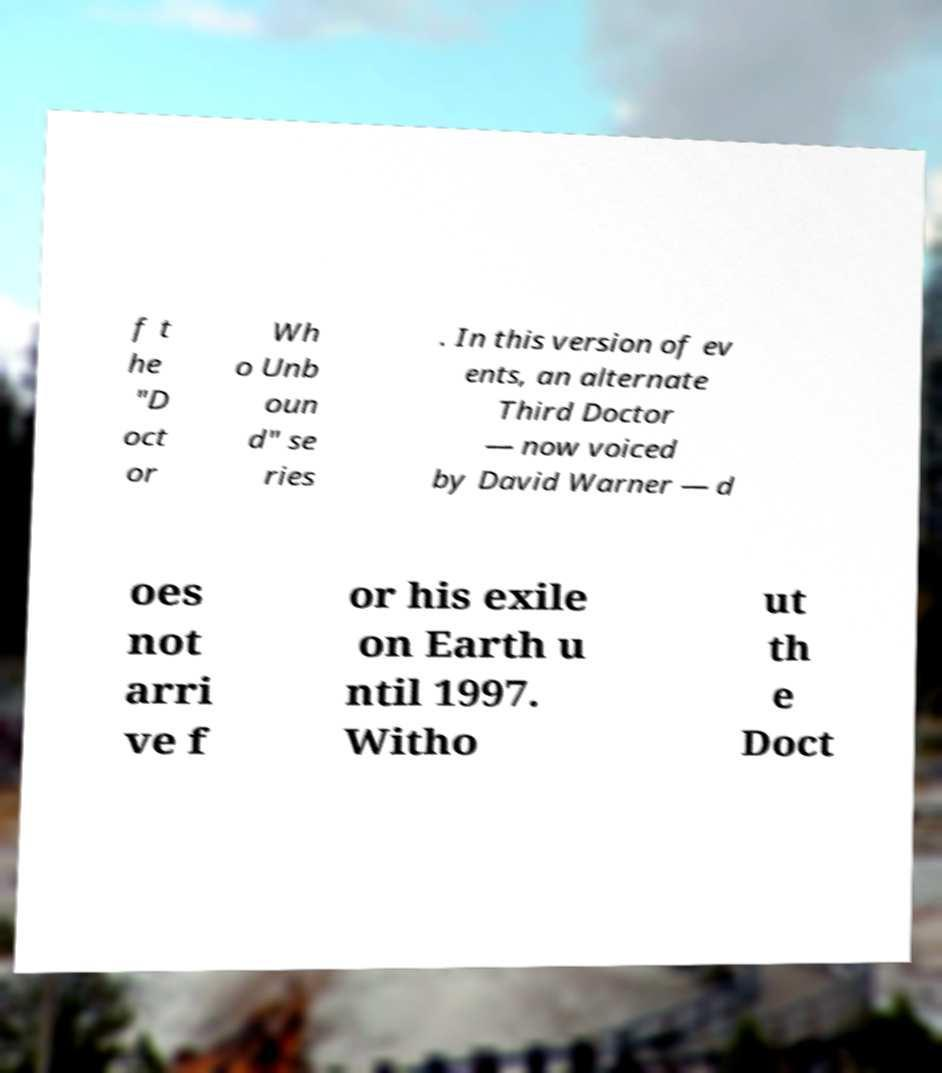Could you assist in decoding the text presented in this image and type it out clearly? f t he "D oct or Wh o Unb oun d" se ries . In this version of ev ents, an alternate Third Doctor — now voiced by David Warner — d oes not arri ve f or his exile on Earth u ntil 1997. Witho ut th e Doct 